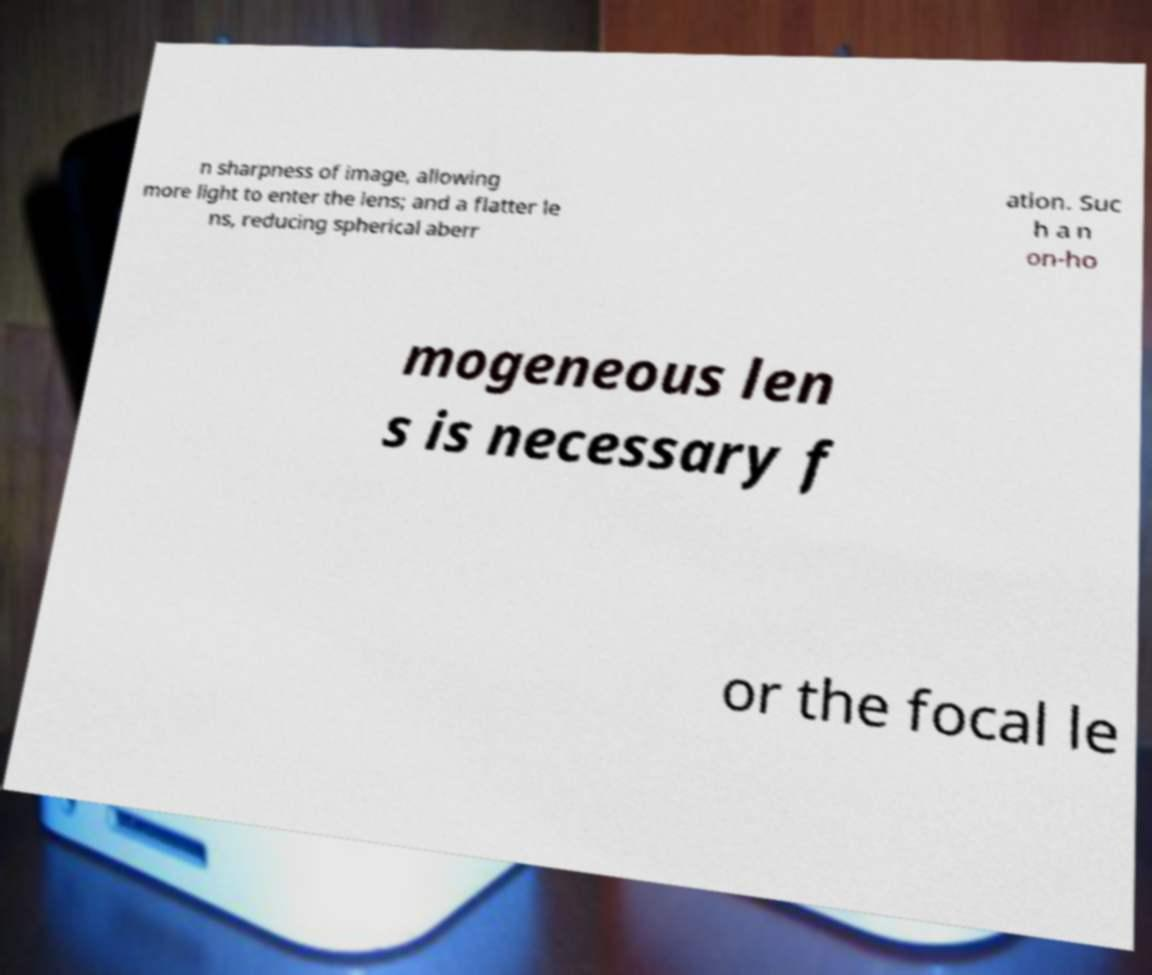What messages or text are displayed in this image? I need them in a readable, typed format. n sharpness of image, allowing more light to enter the lens; and a flatter le ns, reducing spherical aberr ation. Suc h a n on-ho mogeneous len s is necessary f or the focal le 